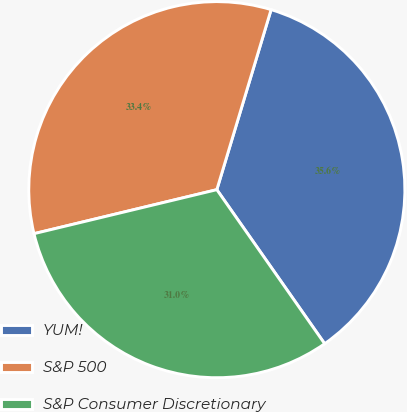Convert chart. <chart><loc_0><loc_0><loc_500><loc_500><pie_chart><fcel>YUM!<fcel>S&P 500<fcel>S&P Consumer Discretionary<nl><fcel>35.62%<fcel>33.42%<fcel>30.96%<nl></chart> 